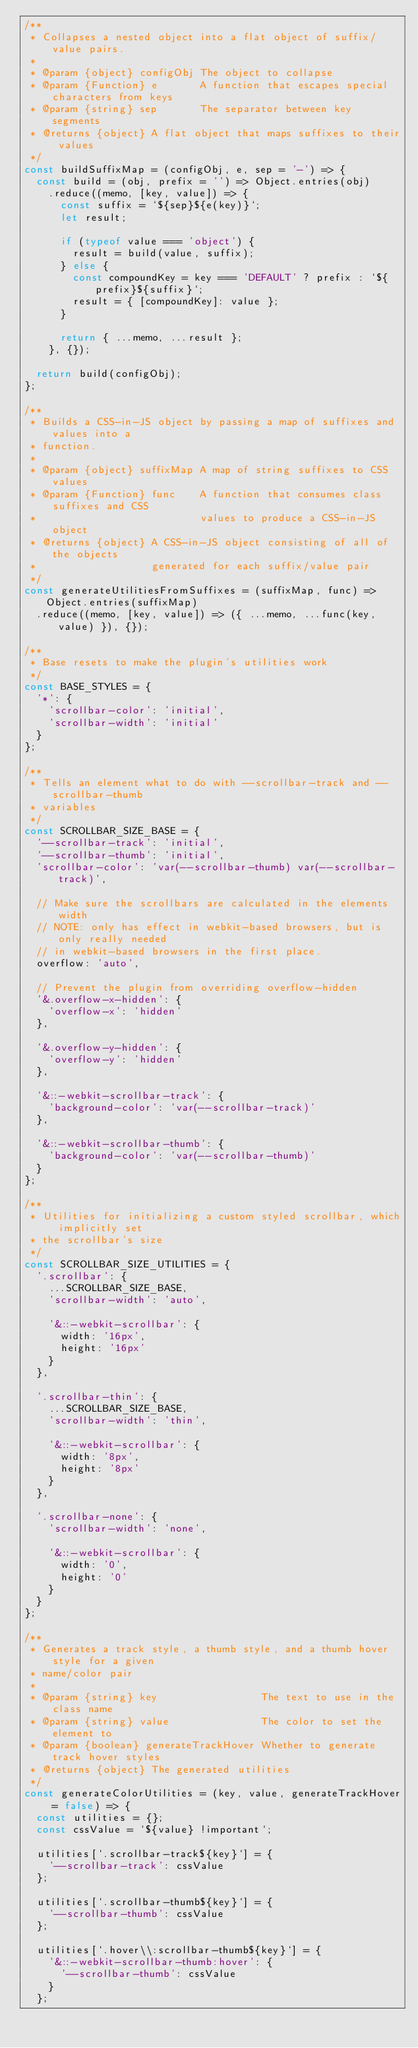Convert code to text. <code><loc_0><loc_0><loc_500><loc_500><_JavaScript_>/**
 * Collapses a nested object into a flat object of suffix/value pairs.
 *
 * @param {object} configObj The object to collapse
 * @param {Function} e       A function that escapes special characters from keys
 * @param {string} sep       The separator between key segments
 * @returns {object} A flat object that maps suffixes to their values
 */
const buildSuffixMap = (configObj, e, sep = '-') => {
  const build = (obj, prefix = '') => Object.entries(obj)
    .reduce((memo, [key, value]) => {
      const suffix = `${sep}${e(key)}`;
      let result;

      if (typeof value === 'object') {
        result = build(value, suffix);
      } else {
        const compoundKey = key === 'DEFAULT' ? prefix : `${prefix}${suffix}`;
        result = { [compoundKey]: value };
      }

      return { ...memo, ...result };
    }, {});

  return build(configObj);
};

/**
 * Builds a CSS-in-JS object by passing a map of suffixes and values into a
 * function.
 *
 * @param {object} suffixMap A map of string suffixes to CSS values
 * @param {Function} func    A function that consumes class suffixes and CSS
 *                           values to produce a CSS-in-JS object
 * @returns {object} A CSS-in-JS object consisting of all of the objects
 *                   generated for each suffix/value pair
 */
const generateUtilitiesFromSuffixes = (suffixMap, func) => Object.entries(suffixMap)
  .reduce((memo, [key, value]) => ({ ...memo, ...func(key, value) }), {});

/**
 * Base resets to make the plugin's utilities work
 */
const BASE_STYLES = {
  '*': {
    'scrollbar-color': 'initial',
    'scrollbar-width': 'initial'
  }
};

/**
 * Tells an element what to do with --scrollbar-track and --scrollbar-thumb
 * variables
 */
const SCROLLBAR_SIZE_BASE = {
  '--scrollbar-track': 'initial',
  '--scrollbar-thumb': 'initial',
  'scrollbar-color': 'var(--scrollbar-thumb) var(--scrollbar-track)',

  // Make sure the scrollbars are calculated in the elements width
  // NOTE: only has effect in webkit-based browsers, but is only really needed
  // in webkit-based browsers in the first place.
  overflow: 'auto',

  // Prevent the plugin from overriding overflow-hidden
  '&.overflow-x-hidden': {
    'overflow-x': 'hidden'
  },

  '&.overflow-y-hidden': {
    'overflow-y': 'hidden'
  },

  '&::-webkit-scrollbar-track': {
    'background-color': 'var(--scrollbar-track)'
  },

  '&::-webkit-scrollbar-thumb': {
    'background-color': 'var(--scrollbar-thumb)'
  }
};

/**
 * Utilities for initializing a custom styled scrollbar, which implicitly set
 * the scrollbar's size
 */
const SCROLLBAR_SIZE_UTILITIES = {
  '.scrollbar': {
    ...SCROLLBAR_SIZE_BASE,
    'scrollbar-width': 'auto',

    '&::-webkit-scrollbar': {
      width: '16px',
      height: '16px'
    }
  },

  '.scrollbar-thin': {
    ...SCROLLBAR_SIZE_BASE,
    'scrollbar-width': 'thin',

    '&::-webkit-scrollbar': {
      width: '8px',
      height: '8px'
    }
  },

  '.scrollbar-none': {
    'scrollbar-width': 'none',

    '&::-webkit-scrollbar': {
      width: '0',
      height: '0'
    }
  }
};

/**
 * Generates a track style, a thumb style, and a thumb hover style for a given
 * name/color pair
 *
 * @param {string} key                 The text to use in the class name
 * @param {string} value               The color to set the element to
 * @param {boolean} generateTrackHover Whether to generate track hover styles
 * @returns {object} The generated utilities
 */
const generateColorUtilities = (key, value, generateTrackHover = false) => {
  const utilities = {};
  const cssValue = `${value} !important`;

  utilities[`.scrollbar-track${key}`] = {
    '--scrollbar-track': cssValue
  };

  utilities[`.scrollbar-thumb${key}`] = {
    '--scrollbar-thumb': cssValue
  };

  utilities[`.hover\\:scrollbar-thumb${key}`] = {
    '&::-webkit-scrollbar-thumb:hover': {
      '--scrollbar-thumb': cssValue
    }
  };
</code> 